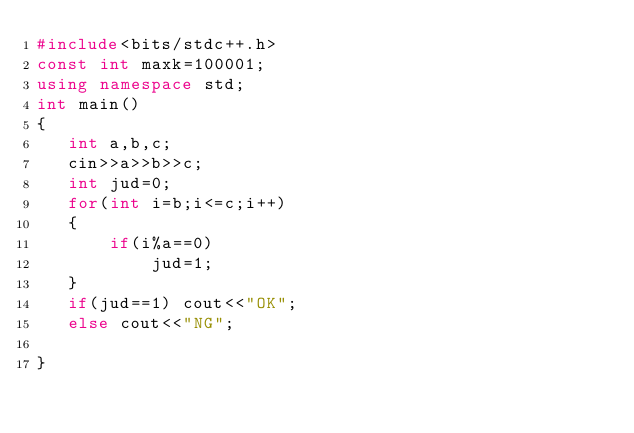Convert code to text. <code><loc_0><loc_0><loc_500><loc_500><_C++_>#include<bits/stdc++.h>
const int maxk=100001;
using namespace std;
int main()
{
   int a,b,c;
   cin>>a>>b>>c;
   int jud=0;
   for(int i=b;i<=c;i++)
   {
       if(i%a==0)
           jud=1;
   }
   if(jud==1) cout<<"OK";
   else cout<<"NG";

}</code> 